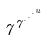Convert formula to latex. <formula><loc_0><loc_0><loc_500><loc_500>7 ^ { 7 ^ { \cdot ^ { \cdot ^ { \cdot ^ { u } } } } }</formula> 